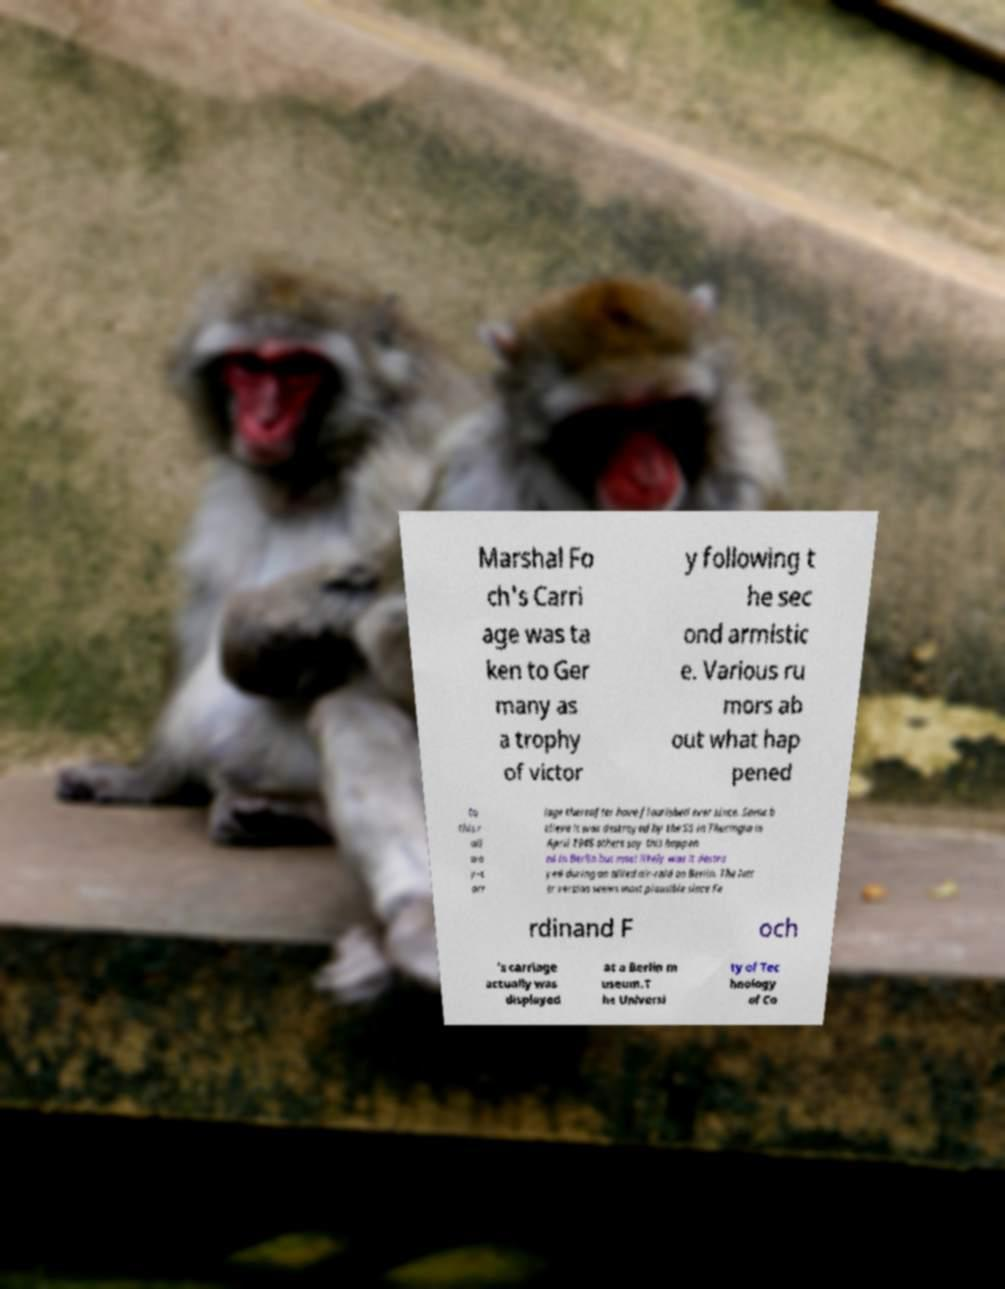Can you read and provide the text displayed in the image?This photo seems to have some interesting text. Can you extract and type it out for me? Marshal Fo ch's Carri age was ta ken to Ger many as a trophy of victor y following t he sec ond armistic e. Various ru mors ab out what hap pened to this r ail wa y-c arr iage thereafter have flourished ever since. Some b elieve it was destroyed by the SS in Thuringia in April 1945 others say this happen ed in Berlin but most likely was it destro yed during an allied air-raid on Berlin. The latt er version seems most plausible since Fe rdinand F och 's carriage actually was displayed at a Berlin m useum.T he Universi ty of Tec hnology of Co 